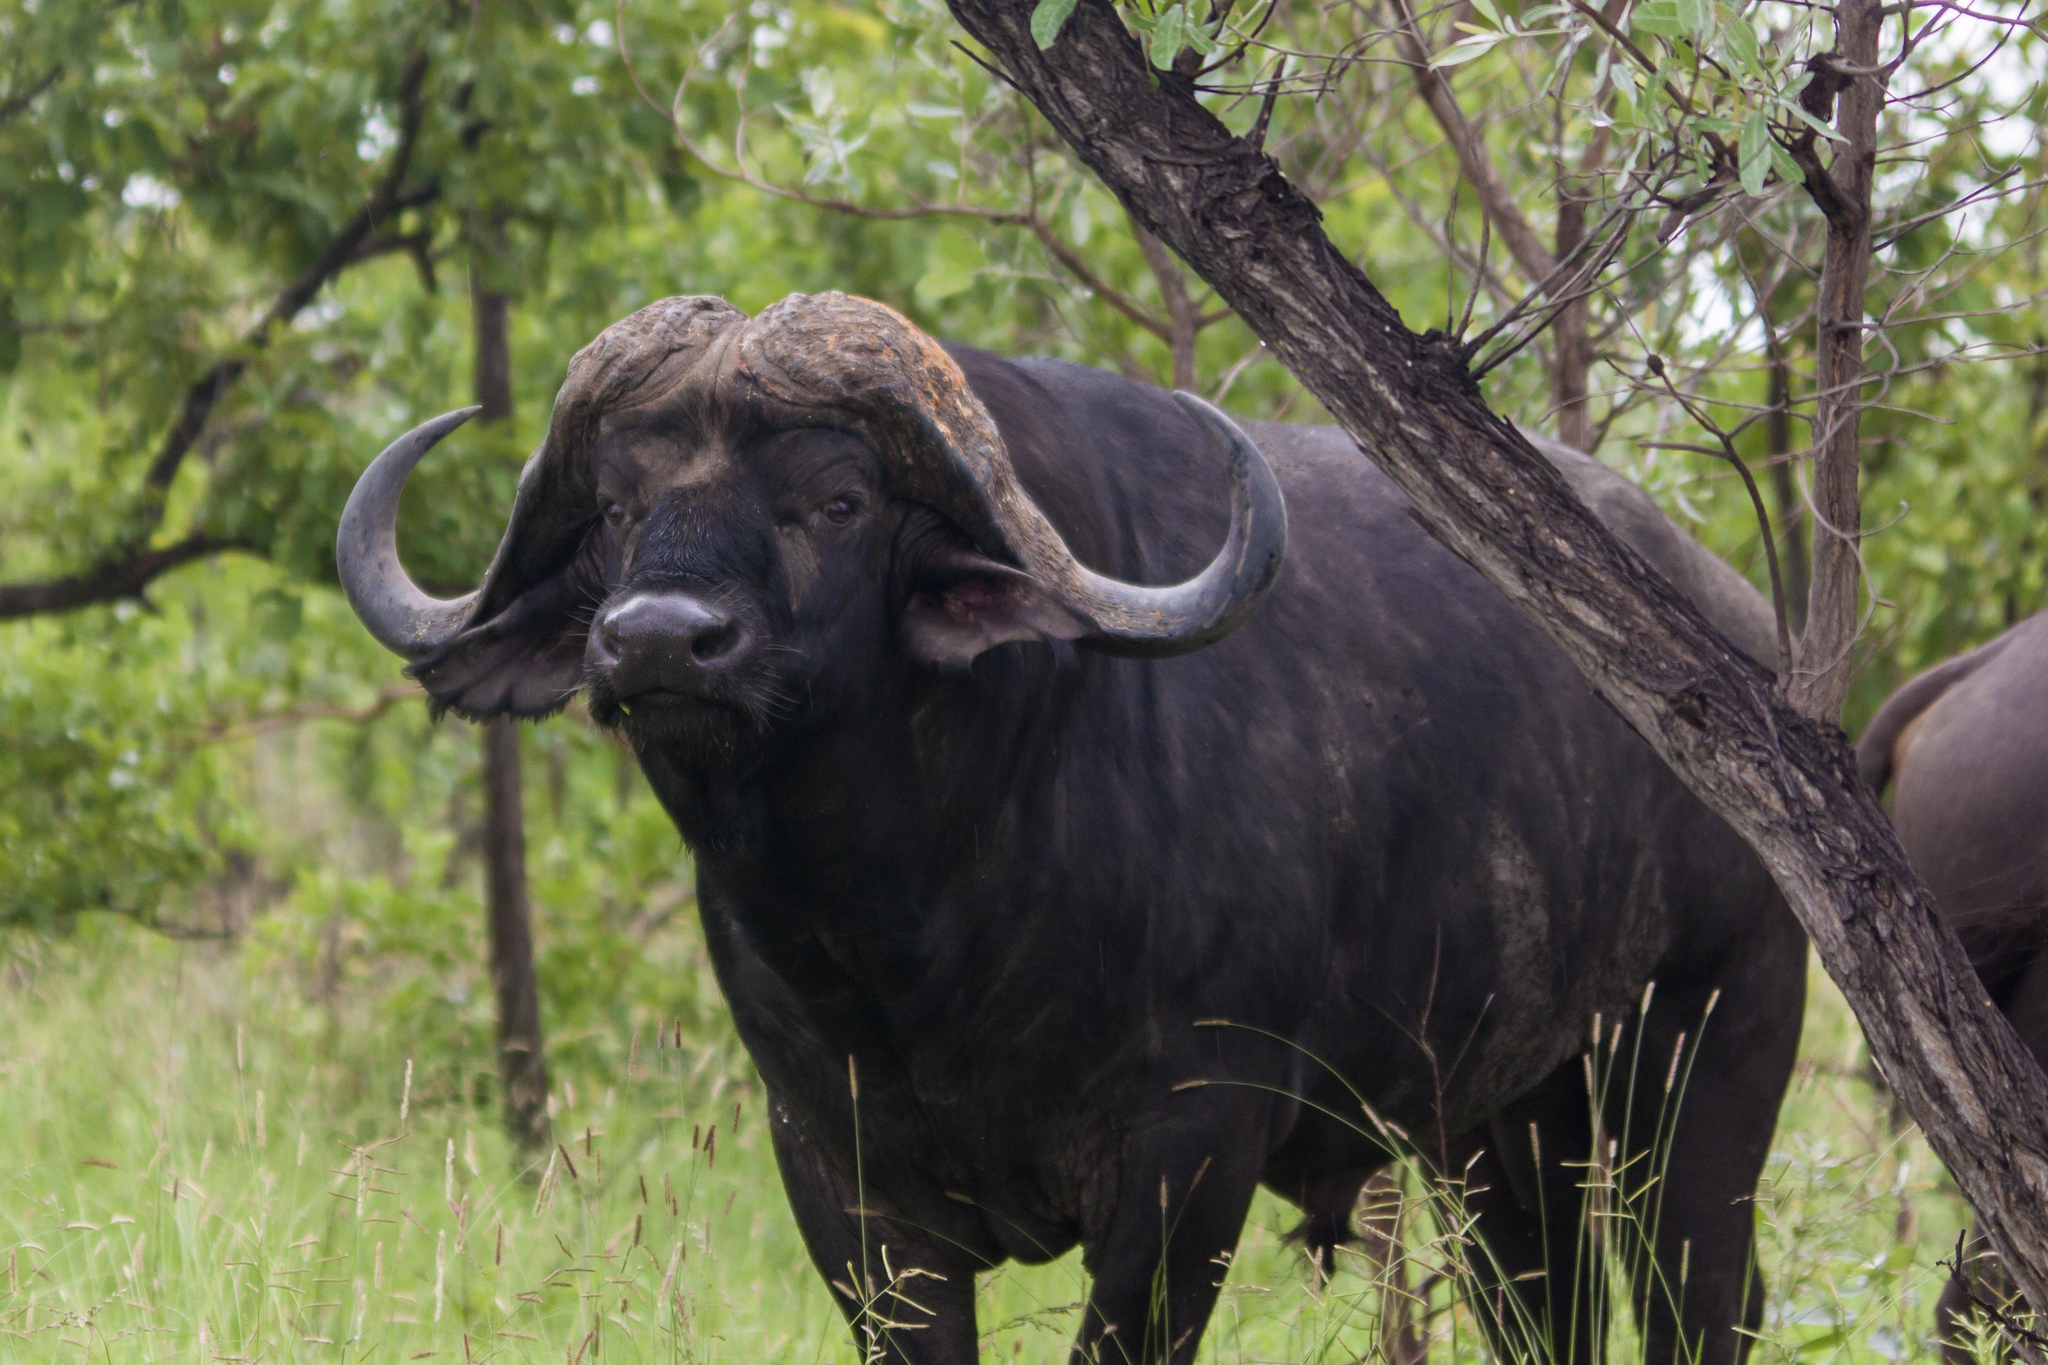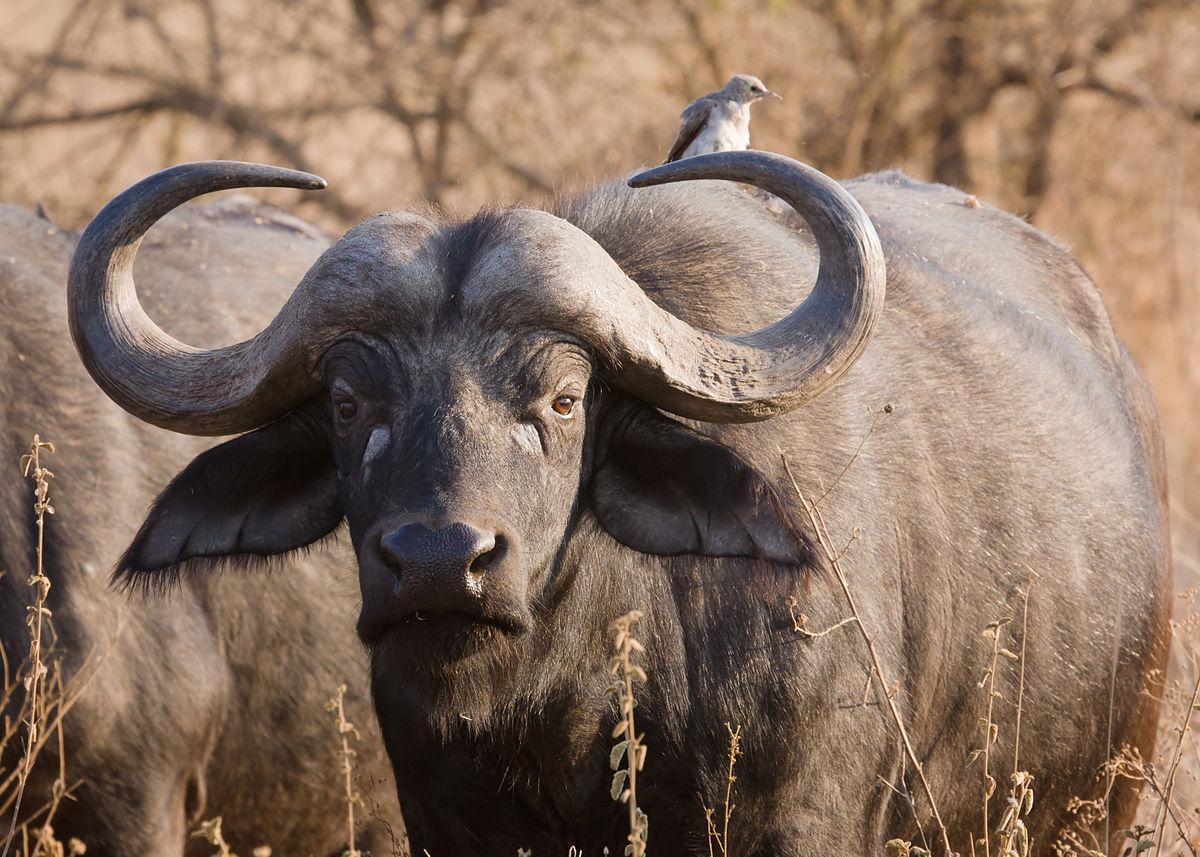The first image is the image on the left, the second image is the image on the right. Examine the images to the left and right. Is the description "An action scene with a water buffalo features a maned lion." accurate? Answer yes or no. No. The first image is the image on the left, the second image is the image on the right. Assess this claim about the two images: "One image is an action scene involving at least one water buffalo and one lion, while the other image is a single water buffalo facing forward.". Correct or not? Answer yes or no. No. 